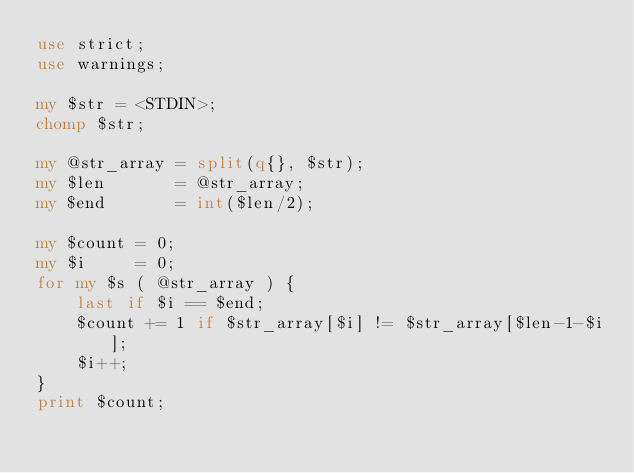<code> <loc_0><loc_0><loc_500><loc_500><_Perl_>use strict;
use warnings;

my $str = <STDIN>;
chomp $str;

my @str_array = split(q{}, $str);
my $len       = @str_array;
my $end       = int($len/2);

my $count = 0;
my $i     = 0;
for my $s ( @str_array ) {
    last if $i == $end;
    $count += 1 if $str_array[$i] != $str_array[$len-1-$i];
    $i++;
}
print $count;</code> 